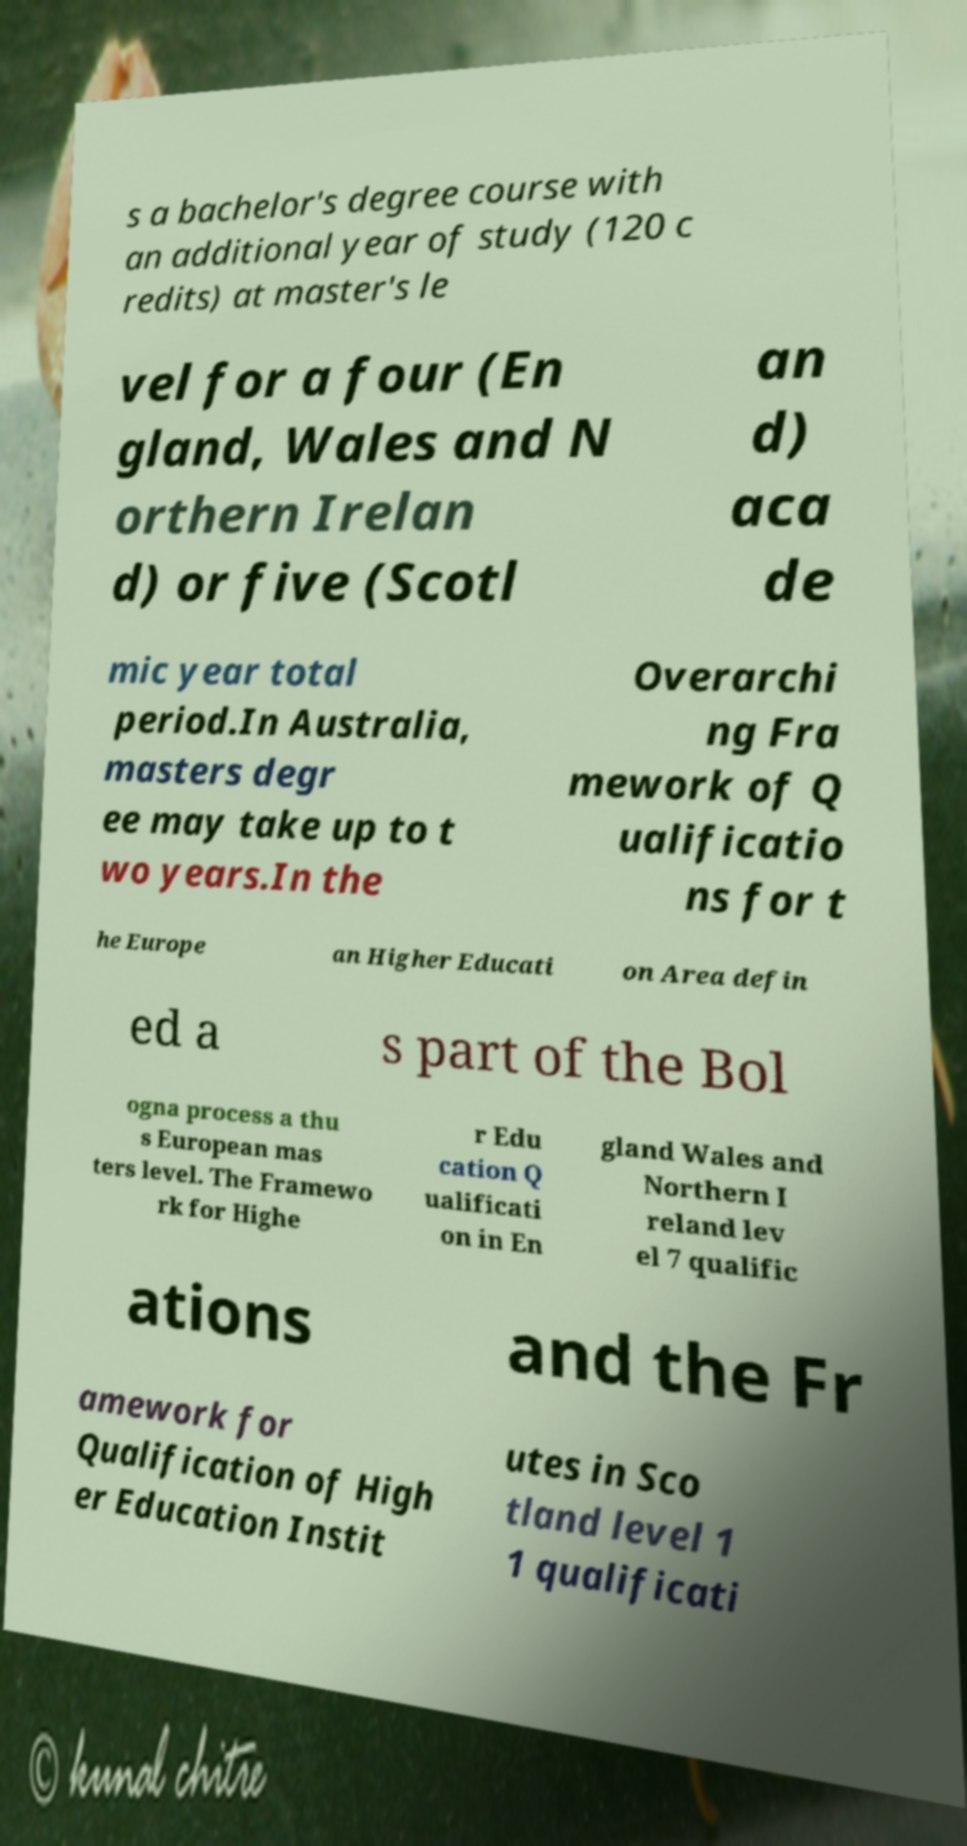For documentation purposes, I need the text within this image transcribed. Could you provide that? s a bachelor's degree course with an additional year of study (120 c redits) at master's le vel for a four (En gland, Wales and N orthern Irelan d) or five (Scotl an d) aca de mic year total period.In Australia, masters degr ee may take up to t wo years.In the Overarchi ng Fra mework of Q ualificatio ns for t he Europe an Higher Educati on Area defin ed a s part of the Bol ogna process a thu s European mas ters level. The Framewo rk for Highe r Edu cation Q ualificati on in En gland Wales and Northern I reland lev el 7 qualific ations and the Fr amework for Qualification of High er Education Instit utes in Sco tland level 1 1 qualificati 